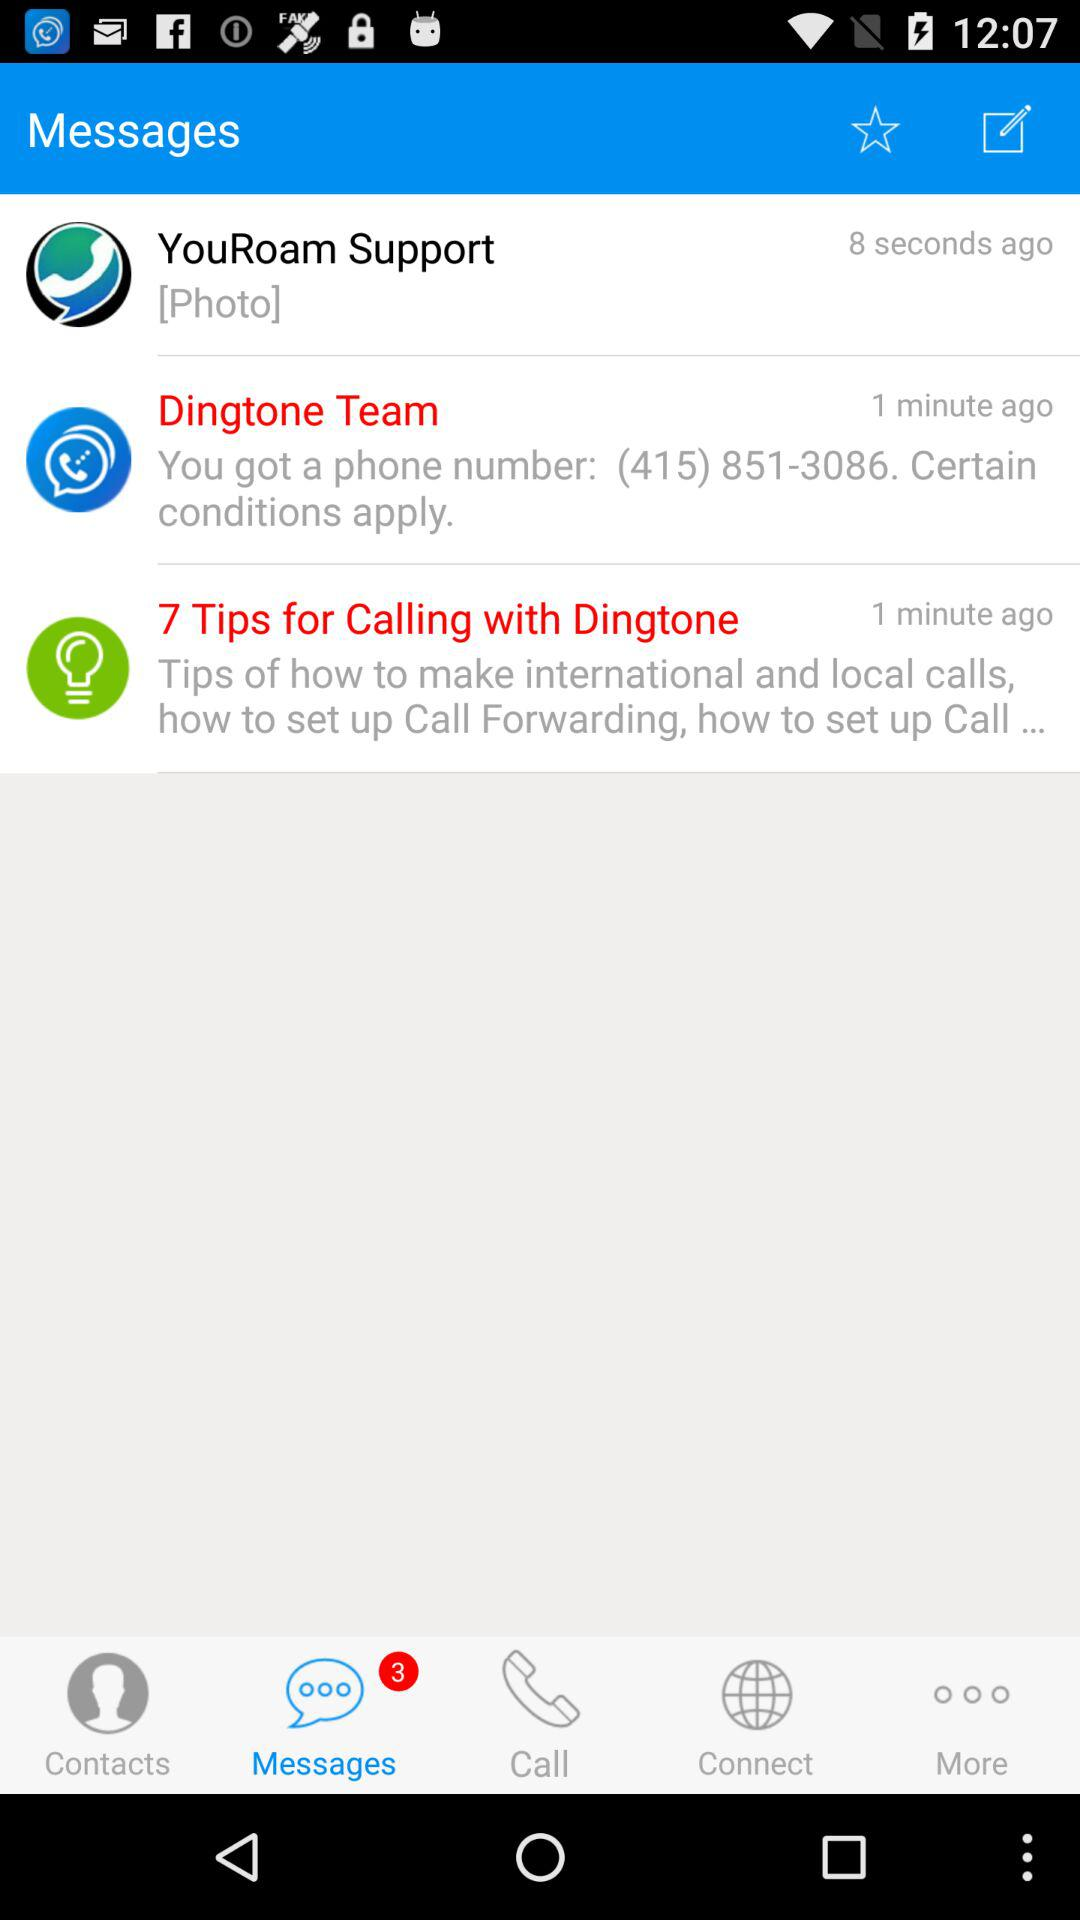Who sent the message 8 seconds ago? The message was sent by "YouRoam Support". 